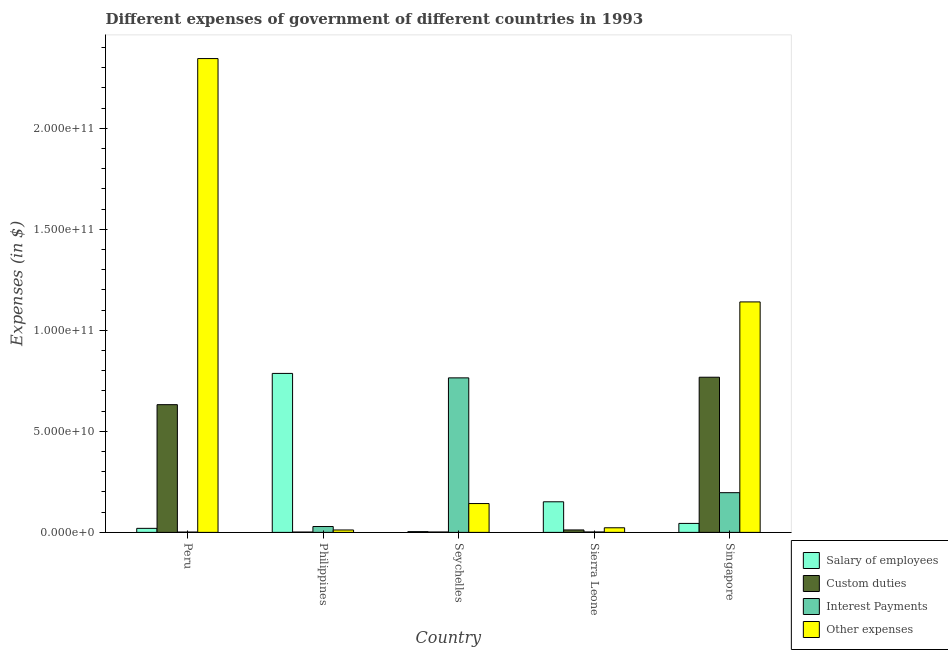How many different coloured bars are there?
Offer a very short reply. 4. How many groups of bars are there?
Ensure brevity in your answer.  5. Are the number of bars per tick equal to the number of legend labels?
Your answer should be very brief. Yes. How many bars are there on the 1st tick from the left?
Give a very brief answer. 4. What is the label of the 5th group of bars from the left?
Make the answer very short. Singapore. In how many cases, is the number of bars for a given country not equal to the number of legend labels?
Ensure brevity in your answer.  0. What is the amount spent on custom duties in Peru?
Your answer should be very brief. 6.32e+1. Across all countries, what is the maximum amount spent on interest payments?
Provide a short and direct response. 7.65e+1. Across all countries, what is the minimum amount spent on interest payments?
Give a very brief answer. 1.57e+08. In which country was the amount spent on custom duties maximum?
Your response must be concise. Singapore. In which country was the amount spent on salary of employees minimum?
Your response must be concise. Seychelles. What is the total amount spent on other expenses in the graph?
Ensure brevity in your answer.  3.66e+11. What is the difference between the amount spent on other expenses in Philippines and that in Seychelles?
Provide a succinct answer. -1.31e+1. What is the difference between the amount spent on custom duties in Sierra Leone and the amount spent on salary of employees in Peru?
Make the answer very short. -7.89e+08. What is the average amount spent on custom duties per country?
Make the answer very short. 2.83e+1. What is the difference between the amount spent on interest payments and amount spent on other expenses in Singapore?
Give a very brief answer. -9.44e+1. In how many countries, is the amount spent on other expenses greater than 220000000000 $?
Provide a succinct answer. 1. What is the ratio of the amount spent on other expenses in Seychelles to that in Singapore?
Make the answer very short. 0.13. Is the amount spent on custom duties in Seychelles less than that in Sierra Leone?
Give a very brief answer. Yes. What is the difference between the highest and the second highest amount spent on interest payments?
Offer a terse response. 5.68e+1. What is the difference between the highest and the lowest amount spent on custom duties?
Give a very brief answer. 7.66e+1. Is the sum of the amount spent on custom duties in Philippines and Singapore greater than the maximum amount spent on salary of employees across all countries?
Provide a short and direct response. No. Is it the case that in every country, the sum of the amount spent on salary of employees and amount spent on custom duties is greater than the sum of amount spent on other expenses and amount spent on interest payments?
Make the answer very short. No. What does the 4th bar from the left in Seychelles represents?
Give a very brief answer. Other expenses. What does the 1st bar from the right in Philippines represents?
Your answer should be compact. Other expenses. How many countries are there in the graph?
Offer a very short reply. 5. What is the difference between two consecutive major ticks on the Y-axis?
Your answer should be very brief. 5.00e+1. Does the graph contain any zero values?
Provide a succinct answer. No. Does the graph contain grids?
Your answer should be very brief. No. What is the title of the graph?
Offer a terse response. Different expenses of government of different countries in 1993. What is the label or title of the X-axis?
Offer a terse response. Country. What is the label or title of the Y-axis?
Offer a terse response. Expenses (in $). What is the Expenses (in $) of Salary of employees in Peru?
Provide a succinct answer. 2.00e+09. What is the Expenses (in $) in Custom duties in Peru?
Keep it short and to the point. 6.32e+1. What is the Expenses (in $) in Interest Payments in Peru?
Ensure brevity in your answer.  1.57e+08. What is the Expenses (in $) in Other expenses in Peru?
Give a very brief answer. 2.35e+11. What is the Expenses (in $) of Salary of employees in Philippines?
Ensure brevity in your answer.  7.87e+1. What is the Expenses (in $) in Custom duties in Philippines?
Make the answer very short. 1.71e+08. What is the Expenses (in $) in Interest Payments in Philippines?
Your answer should be very brief. 2.90e+09. What is the Expenses (in $) of Other expenses in Philippines?
Provide a succinct answer. 1.19e+09. What is the Expenses (in $) in Salary of employees in Seychelles?
Your answer should be compact. 3.80e+08. What is the Expenses (in $) of Custom duties in Seychelles?
Provide a short and direct response. 1.98e+08. What is the Expenses (in $) of Interest Payments in Seychelles?
Offer a terse response. 7.65e+1. What is the Expenses (in $) of Other expenses in Seychelles?
Offer a terse response. 1.43e+1. What is the Expenses (in $) of Salary of employees in Sierra Leone?
Your answer should be very brief. 1.51e+1. What is the Expenses (in $) in Custom duties in Sierra Leone?
Provide a short and direct response. 1.21e+09. What is the Expenses (in $) in Interest Payments in Sierra Leone?
Keep it short and to the point. 2.10e+08. What is the Expenses (in $) in Other expenses in Sierra Leone?
Your response must be concise. 2.28e+09. What is the Expenses (in $) of Salary of employees in Singapore?
Keep it short and to the point. 4.44e+09. What is the Expenses (in $) in Custom duties in Singapore?
Your answer should be compact. 7.68e+1. What is the Expenses (in $) of Interest Payments in Singapore?
Your answer should be compact. 1.97e+1. What is the Expenses (in $) of Other expenses in Singapore?
Provide a short and direct response. 1.14e+11. Across all countries, what is the maximum Expenses (in $) of Salary of employees?
Provide a short and direct response. 7.87e+1. Across all countries, what is the maximum Expenses (in $) in Custom duties?
Your answer should be very brief. 7.68e+1. Across all countries, what is the maximum Expenses (in $) in Interest Payments?
Provide a succinct answer. 7.65e+1. Across all countries, what is the maximum Expenses (in $) in Other expenses?
Offer a very short reply. 2.35e+11. Across all countries, what is the minimum Expenses (in $) in Salary of employees?
Provide a short and direct response. 3.80e+08. Across all countries, what is the minimum Expenses (in $) of Custom duties?
Your response must be concise. 1.71e+08. Across all countries, what is the minimum Expenses (in $) in Interest Payments?
Your answer should be very brief. 1.57e+08. Across all countries, what is the minimum Expenses (in $) in Other expenses?
Ensure brevity in your answer.  1.19e+09. What is the total Expenses (in $) in Salary of employees in the graph?
Give a very brief answer. 1.01e+11. What is the total Expenses (in $) in Custom duties in the graph?
Offer a very short reply. 1.42e+11. What is the total Expenses (in $) in Interest Payments in the graph?
Your response must be concise. 9.94e+1. What is the total Expenses (in $) in Other expenses in the graph?
Keep it short and to the point. 3.66e+11. What is the difference between the Expenses (in $) of Salary of employees in Peru and that in Philippines?
Your answer should be very brief. -7.67e+1. What is the difference between the Expenses (in $) in Custom duties in Peru and that in Philippines?
Your response must be concise. 6.31e+1. What is the difference between the Expenses (in $) in Interest Payments in Peru and that in Philippines?
Provide a succinct answer. -2.74e+09. What is the difference between the Expenses (in $) in Other expenses in Peru and that in Philippines?
Ensure brevity in your answer.  2.33e+11. What is the difference between the Expenses (in $) of Salary of employees in Peru and that in Seychelles?
Provide a short and direct response. 1.62e+09. What is the difference between the Expenses (in $) of Custom duties in Peru and that in Seychelles?
Your answer should be compact. 6.30e+1. What is the difference between the Expenses (in $) of Interest Payments in Peru and that in Seychelles?
Keep it short and to the point. -7.63e+1. What is the difference between the Expenses (in $) of Other expenses in Peru and that in Seychelles?
Make the answer very short. 2.20e+11. What is the difference between the Expenses (in $) of Salary of employees in Peru and that in Sierra Leone?
Give a very brief answer. -1.31e+1. What is the difference between the Expenses (in $) of Custom duties in Peru and that in Sierra Leone?
Your answer should be very brief. 6.20e+1. What is the difference between the Expenses (in $) of Interest Payments in Peru and that in Sierra Leone?
Provide a succinct answer. -5.28e+07. What is the difference between the Expenses (in $) of Other expenses in Peru and that in Sierra Leone?
Keep it short and to the point. 2.32e+11. What is the difference between the Expenses (in $) of Salary of employees in Peru and that in Singapore?
Your answer should be very brief. -2.44e+09. What is the difference between the Expenses (in $) of Custom duties in Peru and that in Singapore?
Offer a terse response. -1.36e+1. What is the difference between the Expenses (in $) in Interest Payments in Peru and that in Singapore?
Make the answer very short. -1.95e+1. What is the difference between the Expenses (in $) in Other expenses in Peru and that in Singapore?
Provide a short and direct response. 1.20e+11. What is the difference between the Expenses (in $) in Salary of employees in Philippines and that in Seychelles?
Offer a very short reply. 7.83e+1. What is the difference between the Expenses (in $) in Custom duties in Philippines and that in Seychelles?
Make the answer very short. -2.69e+07. What is the difference between the Expenses (in $) in Interest Payments in Philippines and that in Seychelles?
Your answer should be compact. -7.36e+1. What is the difference between the Expenses (in $) of Other expenses in Philippines and that in Seychelles?
Make the answer very short. -1.31e+1. What is the difference between the Expenses (in $) in Salary of employees in Philippines and that in Sierra Leone?
Provide a short and direct response. 6.36e+1. What is the difference between the Expenses (in $) in Custom duties in Philippines and that in Sierra Leone?
Give a very brief answer. -1.04e+09. What is the difference between the Expenses (in $) of Interest Payments in Philippines and that in Sierra Leone?
Provide a succinct answer. 2.69e+09. What is the difference between the Expenses (in $) of Other expenses in Philippines and that in Sierra Leone?
Offer a terse response. -1.09e+09. What is the difference between the Expenses (in $) in Salary of employees in Philippines and that in Singapore?
Give a very brief answer. 7.43e+1. What is the difference between the Expenses (in $) of Custom duties in Philippines and that in Singapore?
Your response must be concise. -7.66e+1. What is the difference between the Expenses (in $) in Interest Payments in Philippines and that in Singapore?
Your answer should be very brief. -1.68e+1. What is the difference between the Expenses (in $) of Other expenses in Philippines and that in Singapore?
Keep it short and to the point. -1.13e+11. What is the difference between the Expenses (in $) in Salary of employees in Seychelles and that in Sierra Leone?
Make the answer very short. -1.48e+1. What is the difference between the Expenses (in $) in Custom duties in Seychelles and that in Sierra Leone?
Offer a very short reply. -1.01e+09. What is the difference between the Expenses (in $) of Interest Payments in Seychelles and that in Sierra Leone?
Your response must be concise. 7.63e+1. What is the difference between the Expenses (in $) in Other expenses in Seychelles and that in Sierra Leone?
Your answer should be very brief. 1.20e+1. What is the difference between the Expenses (in $) of Salary of employees in Seychelles and that in Singapore?
Your response must be concise. -4.06e+09. What is the difference between the Expenses (in $) in Custom duties in Seychelles and that in Singapore?
Give a very brief answer. -7.66e+1. What is the difference between the Expenses (in $) of Interest Payments in Seychelles and that in Singapore?
Your response must be concise. 5.68e+1. What is the difference between the Expenses (in $) in Other expenses in Seychelles and that in Singapore?
Provide a succinct answer. -9.98e+1. What is the difference between the Expenses (in $) in Salary of employees in Sierra Leone and that in Singapore?
Your answer should be compact. 1.07e+1. What is the difference between the Expenses (in $) of Custom duties in Sierra Leone and that in Singapore?
Keep it short and to the point. -7.56e+1. What is the difference between the Expenses (in $) of Interest Payments in Sierra Leone and that in Singapore?
Your response must be concise. -1.94e+1. What is the difference between the Expenses (in $) in Other expenses in Sierra Leone and that in Singapore?
Keep it short and to the point. -1.12e+11. What is the difference between the Expenses (in $) of Salary of employees in Peru and the Expenses (in $) of Custom duties in Philippines?
Offer a very short reply. 1.83e+09. What is the difference between the Expenses (in $) in Salary of employees in Peru and the Expenses (in $) in Interest Payments in Philippines?
Offer a very short reply. -9.03e+08. What is the difference between the Expenses (in $) in Salary of employees in Peru and the Expenses (in $) in Other expenses in Philippines?
Keep it short and to the point. 8.09e+08. What is the difference between the Expenses (in $) in Custom duties in Peru and the Expenses (in $) in Interest Payments in Philippines?
Provide a succinct answer. 6.03e+1. What is the difference between the Expenses (in $) in Custom duties in Peru and the Expenses (in $) in Other expenses in Philippines?
Your answer should be very brief. 6.20e+1. What is the difference between the Expenses (in $) in Interest Payments in Peru and the Expenses (in $) in Other expenses in Philippines?
Offer a terse response. -1.03e+09. What is the difference between the Expenses (in $) in Salary of employees in Peru and the Expenses (in $) in Custom duties in Seychelles?
Your answer should be compact. 1.80e+09. What is the difference between the Expenses (in $) of Salary of employees in Peru and the Expenses (in $) of Interest Payments in Seychelles?
Your answer should be compact. -7.45e+1. What is the difference between the Expenses (in $) of Salary of employees in Peru and the Expenses (in $) of Other expenses in Seychelles?
Keep it short and to the point. -1.23e+1. What is the difference between the Expenses (in $) of Custom duties in Peru and the Expenses (in $) of Interest Payments in Seychelles?
Provide a short and direct response. -1.33e+1. What is the difference between the Expenses (in $) of Custom duties in Peru and the Expenses (in $) of Other expenses in Seychelles?
Keep it short and to the point. 4.90e+1. What is the difference between the Expenses (in $) of Interest Payments in Peru and the Expenses (in $) of Other expenses in Seychelles?
Ensure brevity in your answer.  -1.41e+1. What is the difference between the Expenses (in $) in Salary of employees in Peru and the Expenses (in $) in Custom duties in Sierra Leone?
Your answer should be compact. 7.89e+08. What is the difference between the Expenses (in $) in Salary of employees in Peru and the Expenses (in $) in Interest Payments in Sierra Leone?
Give a very brief answer. 1.79e+09. What is the difference between the Expenses (in $) in Salary of employees in Peru and the Expenses (in $) in Other expenses in Sierra Leone?
Provide a short and direct response. -2.80e+08. What is the difference between the Expenses (in $) of Custom duties in Peru and the Expenses (in $) of Interest Payments in Sierra Leone?
Provide a succinct answer. 6.30e+1. What is the difference between the Expenses (in $) in Custom duties in Peru and the Expenses (in $) in Other expenses in Sierra Leone?
Ensure brevity in your answer.  6.09e+1. What is the difference between the Expenses (in $) in Interest Payments in Peru and the Expenses (in $) in Other expenses in Sierra Leone?
Your answer should be very brief. -2.12e+09. What is the difference between the Expenses (in $) of Salary of employees in Peru and the Expenses (in $) of Custom duties in Singapore?
Provide a short and direct response. -7.48e+1. What is the difference between the Expenses (in $) of Salary of employees in Peru and the Expenses (in $) of Interest Payments in Singapore?
Provide a succinct answer. -1.77e+1. What is the difference between the Expenses (in $) in Salary of employees in Peru and the Expenses (in $) in Other expenses in Singapore?
Provide a short and direct response. -1.12e+11. What is the difference between the Expenses (in $) in Custom duties in Peru and the Expenses (in $) in Interest Payments in Singapore?
Provide a short and direct response. 4.36e+1. What is the difference between the Expenses (in $) in Custom duties in Peru and the Expenses (in $) in Other expenses in Singapore?
Keep it short and to the point. -5.09e+1. What is the difference between the Expenses (in $) in Interest Payments in Peru and the Expenses (in $) in Other expenses in Singapore?
Give a very brief answer. -1.14e+11. What is the difference between the Expenses (in $) of Salary of employees in Philippines and the Expenses (in $) of Custom duties in Seychelles?
Make the answer very short. 7.85e+1. What is the difference between the Expenses (in $) of Salary of employees in Philippines and the Expenses (in $) of Interest Payments in Seychelles?
Provide a short and direct response. 2.20e+09. What is the difference between the Expenses (in $) in Salary of employees in Philippines and the Expenses (in $) in Other expenses in Seychelles?
Make the answer very short. 6.44e+1. What is the difference between the Expenses (in $) in Custom duties in Philippines and the Expenses (in $) in Interest Payments in Seychelles?
Your response must be concise. -7.63e+1. What is the difference between the Expenses (in $) of Custom duties in Philippines and the Expenses (in $) of Other expenses in Seychelles?
Give a very brief answer. -1.41e+1. What is the difference between the Expenses (in $) in Interest Payments in Philippines and the Expenses (in $) in Other expenses in Seychelles?
Provide a succinct answer. -1.14e+1. What is the difference between the Expenses (in $) of Salary of employees in Philippines and the Expenses (in $) of Custom duties in Sierra Leone?
Give a very brief answer. 7.75e+1. What is the difference between the Expenses (in $) of Salary of employees in Philippines and the Expenses (in $) of Interest Payments in Sierra Leone?
Provide a short and direct response. 7.85e+1. What is the difference between the Expenses (in $) in Salary of employees in Philippines and the Expenses (in $) in Other expenses in Sierra Leone?
Your answer should be very brief. 7.64e+1. What is the difference between the Expenses (in $) of Custom duties in Philippines and the Expenses (in $) of Interest Payments in Sierra Leone?
Provide a short and direct response. -3.86e+07. What is the difference between the Expenses (in $) in Custom duties in Philippines and the Expenses (in $) in Other expenses in Sierra Leone?
Make the answer very short. -2.11e+09. What is the difference between the Expenses (in $) of Interest Payments in Philippines and the Expenses (in $) of Other expenses in Sierra Leone?
Keep it short and to the point. 6.23e+08. What is the difference between the Expenses (in $) of Salary of employees in Philippines and the Expenses (in $) of Custom duties in Singapore?
Your response must be concise. 1.88e+09. What is the difference between the Expenses (in $) in Salary of employees in Philippines and the Expenses (in $) in Interest Payments in Singapore?
Keep it short and to the point. 5.90e+1. What is the difference between the Expenses (in $) of Salary of employees in Philippines and the Expenses (in $) of Other expenses in Singapore?
Your answer should be very brief. -3.54e+1. What is the difference between the Expenses (in $) of Custom duties in Philippines and the Expenses (in $) of Interest Payments in Singapore?
Your response must be concise. -1.95e+1. What is the difference between the Expenses (in $) in Custom duties in Philippines and the Expenses (in $) in Other expenses in Singapore?
Your answer should be very brief. -1.14e+11. What is the difference between the Expenses (in $) in Interest Payments in Philippines and the Expenses (in $) in Other expenses in Singapore?
Provide a succinct answer. -1.11e+11. What is the difference between the Expenses (in $) of Salary of employees in Seychelles and the Expenses (in $) of Custom duties in Sierra Leone?
Your response must be concise. -8.30e+08. What is the difference between the Expenses (in $) of Salary of employees in Seychelles and the Expenses (in $) of Interest Payments in Sierra Leone?
Your response must be concise. 1.70e+08. What is the difference between the Expenses (in $) in Salary of employees in Seychelles and the Expenses (in $) in Other expenses in Sierra Leone?
Offer a very short reply. -1.90e+09. What is the difference between the Expenses (in $) in Custom duties in Seychelles and the Expenses (in $) in Interest Payments in Sierra Leone?
Provide a succinct answer. -1.17e+07. What is the difference between the Expenses (in $) of Custom duties in Seychelles and the Expenses (in $) of Other expenses in Sierra Leone?
Make the answer very short. -2.08e+09. What is the difference between the Expenses (in $) of Interest Payments in Seychelles and the Expenses (in $) of Other expenses in Sierra Leone?
Make the answer very short. 7.42e+1. What is the difference between the Expenses (in $) in Salary of employees in Seychelles and the Expenses (in $) in Custom duties in Singapore?
Provide a succinct answer. -7.64e+1. What is the difference between the Expenses (in $) in Salary of employees in Seychelles and the Expenses (in $) in Interest Payments in Singapore?
Provide a succinct answer. -1.93e+1. What is the difference between the Expenses (in $) of Salary of employees in Seychelles and the Expenses (in $) of Other expenses in Singapore?
Keep it short and to the point. -1.14e+11. What is the difference between the Expenses (in $) of Custom duties in Seychelles and the Expenses (in $) of Interest Payments in Singapore?
Offer a very short reply. -1.95e+1. What is the difference between the Expenses (in $) of Custom duties in Seychelles and the Expenses (in $) of Other expenses in Singapore?
Provide a succinct answer. -1.14e+11. What is the difference between the Expenses (in $) in Interest Payments in Seychelles and the Expenses (in $) in Other expenses in Singapore?
Your response must be concise. -3.76e+1. What is the difference between the Expenses (in $) in Salary of employees in Sierra Leone and the Expenses (in $) in Custom duties in Singapore?
Your answer should be compact. -6.17e+1. What is the difference between the Expenses (in $) in Salary of employees in Sierra Leone and the Expenses (in $) in Interest Payments in Singapore?
Provide a short and direct response. -4.51e+09. What is the difference between the Expenses (in $) in Salary of employees in Sierra Leone and the Expenses (in $) in Other expenses in Singapore?
Offer a terse response. -9.90e+1. What is the difference between the Expenses (in $) in Custom duties in Sierra Leone and the Expenses (in $) in Interest Payments in Singapore?
Give a very brief answer. -1.84e+1. What is the difference between the Expenses (in $) in Custom duties in Sierra Leone and the Expenses (in $) in Other expenses in Singapore?
Ensure brevity in your answer.  -1.13e+11. What is the difference between the Expenses (in $) in Interest Payments in Sierra Leone and the Expenses (in $) in Other expenses in Singapore?
Offer a terse response. -1.14e+11. What is the average Expenses (in $) in Salary of employees per country?
Your answer should be compact. 2.01e+1. What is the average Expenses (in $) in Custom duties per country?
Your answer should be compact. 2.83e+1. What is the average Expenses (in $) in Interest Payments per country?
Give a very brief answer. 1.99e+1. What is the average Expenses (in $) of Other expenses per country?
Your response must be concise. 7.33e+1. What is the difference between the Expenses (in $) of Salary of employees and Expenses (in $) of Custom duties in Peru?
Ensure brevity in your answer.  -6.12e+1. What is the difference between the Expenses (in $) in Salary of employees and Expenses (in $) in Interest Payments in Peru?
Ensure brevity in your answer.  1.84e+09. What is the difference between the Expenses (in $) in Salary of employees and Expenses (in $) in Other expenses in Peru?
Your answer should be very brief. -2.33e+11. What is the difference between the Expenses (in $) of Custom duties and Expenses (in $) of Interest Payments in Peru?
Make the answer very short. 6.31e+1. What is the difference between the Expenses (in $) in Custom duties and Expenses (in $) in Other expenses in Peru?
Offer a very short reply. -1.71e+11. What is the difference between the Expenses (in $) in Interest Payments and Expenses (in $) in Other expenses in Peru?
Keep it short and to the point. -2.34e+11. What is the difference between the Expenses (in $) of Salary of employees and Expenses (in $) of Custom duties in Philippines?
Provide a short and direct response. 7.85e+1. What is the difference between the Expenses (in $) in Salary of employees and Expenses (in $) in Interest Payments in Philippines?
Your response must be concise. 7.58e+1. What is the difference between the Expenses (in $) in Salary of employees and Expenses (in $) in Other expenses in Philippines?
Your answer should be very brief. 7.75e+1. What is the difference between the Expenses (in $) of Custom duties and Expenses (in $) of Interest Payments in Philippines?
Your answer should be very brief. -2.73e+09. What is the difference between the Expenses (in $) of Custom duties and Expenses (in $) of Other expenses in Philippines?
Your answer should be compact. -1.02e+09. What is the difference between the Expenses (in $) of Interest Payments and Expenses (in $) of Other expenses in Philippines?
Keep it short and to the point. 1.71e+09. What is the difference between the Expenses (in $) in Salary of employees and Expenses (in $) in Custom duties in Seychelles?
Give a very brief answer. 1.82e+08. What is the difference between the Expenses (in $) in Salary of employees and Expenses (in $) in Interest Payments in Seychelles?
Your answer should be very brief. -7.61e+1. What is the difference between the Expenses (in $) of Salary of employees and Expenses (in $) of Other expenses in Seychelles?
Offer a very short reply. -1.39e+1. What is the difference between the Expenses (in $) of Custom duties and Expenses (in $) of Interest Payments in Seychelles?
Offer a terse response. -7.63e+1. What is the difference between the Expenses (in $) of Custom duties and Expenses (in $) of Other expenses in Seychelles?
Make the answer very short. -1.41e+1. What is the difference between the Expenses (in $) in Interest Payments and Expenses (in $) in Other expenses in Seychelles?
Your response must be concise. 6.22e+1. What is the difference between the Expenses (in $) in Salary of employees and Expenses (in $) in Custom duties in Sierra Leone?
Offer a very short reply. 1.39e+1. What is the difference between the Expenses (in $) of Salary of employees and Expenses (in $) of Interest Payments in Sierra Leone?
Offer a very short reply. 1.49e+1. What is the difference between the Expenses (in $) in Salary of employees and Expenses (in $) in Other expenses in Sierra Leone?
Provide a succinct answer. 1.29e+1. What is the difference between the Expenses (in $) in Custom duties and Expenses (in $) in Interest Payments in Sierra Leone?
Provide a short and direct response. 1.00e+09. What is the difference between the Expenses (in $) of Custom duties and Expenses (in $) of Other expenses in Sierra Leone?
Keep it short and to the point. -1.07e+09. What is the difference between the Expenses (in $) of Interest Payments and Expenses (in $) of Other expenses in Sierra Leone?
Provide a succinct answer. -2.07e+09. What is the difference between the Expenses (in $) in Salary of employees and Expenses (in $) in Custom duties in Singapore?
Offer a terse response. -7.24e+1. What is the difference between the Expenses (in $) of Salary of employees and Expenses (in $) of Interest Payments in Singapore?
Your answer should be compact. -1.52e+1. What is the difference between the Expenses (in $) in Salary of employees and Expenses (in $) in Other expenses in Singapore?
Your answer should be very brief. -1.10e+11. What is the difference between the Expenses (in $) of Custom duties and Expenses (in $) of Interest Payments in Singapore?
Give a very brief answer. 5.72e+1. What is the difference between the Expenses (in $) in Custom duties and Expenses (in $) in Other expenses in Singapore?
Your answer should be very brief. -3.73e+1. What is the difference between the Expenses (in $) of Interest Payments and Expenses (in $) of Other expenses in Singapore?
Ensure brevity in your answer.  -9.44e+1. What is the ratio of the Expenses (in $) of Salary of employees in Peru to that in Philippines?
Ensure brevity in your answer.  0.03. What is the ratio of the Expenses (in $) of Custom duties in Peru to that in Philippines?
Offer a terse response. 369.3. What is the ratio of the Expenses (in $) in Interest Payments in Peru to that in Philippines?
Give a very brief answer. 0.05. What is the ratio of the Expenses (in $) in Other expenses in Peru to that in Philippines?
Offer a terse response. 197.1. What is the ratio of the Expenses (in $) in Salary of employees in Peru to that in Seychelles?
Keep it short and to the point. 5.26. What is the ratio of the Expenses (in $) in Custom duties in Peru to that in Seychelles?
Ensure brevity in your answer.  319.12. What is the ratio of the Expenses (in $) of Interest Payments in Peru to that in Seychelles?
Your answer should be compact. 0. What is the ratio of the Expenses (in $) in Other expenses in Peru to that in Seychelles?
Your response must be concise. 16.43. What is the ratio of the Expenses (in $) of Salary of employees in Peru to that in Sierra Leone?
Offer a terse response. 0.13. What is the ratio of the Expenses (in $) in Custom duties in Peru to that in Sierra Leone?
Your answer should be compact. 52.25. What is the ratio of the Expenses (in $) in Interest Payments in Peru to that in Sierra Leone?
Give a very brief answer. 0.75. What is the ratio of the Expenses (in $) in Other expenses in Peru to that in Sierra Leone?
Ensure brevity in your answer.  102.93. What is the ratio of the Expenses (in $) in Salary of employees in Peru to that in Singapore?
Keep it short and to the point. 0.45. What is the ratio of the Expenses (in $) in Custom duties in Peru to that in Singapore?
Provide a succinct answer. 0.82. What is the ratio of the Expenses (in $) in Interest Payments in Peru to that in Singapore?
Provide a succinct answer. 0.01. What is the ratio of the Expenses (in $) in Other expenses in Peru to that in Singapore?
Offer a very short reply. 2.06. What is the ratio of the Expenses (in $) in Salary of employees in Philippines to that in Seychelles?
Your answer should be compact. 207.09. What is the ratio of the Expenses (in $) of Custom duties in Philippines to that in Seychelles?
Offer a terse response. 0.86. What is the ratio of the Expenses (in $) in Interest Payments in Philippines to that in Seychelles?
Provide a short and direct response. 0.04. What is the ratio of the Expenses (in $) in Other expenses in Philippines to that in Seychelles?
Provide a succinct answer. 0.08. What is the ratio of the Expenses (in $) of Salary of employees in Philippines to that in Sierra Leone?
Offer a very short reply. 5.2. What is the ratio of the Expenses (in $) in Custom duties in Philippines to that in Sierra Leone?
Ensure brevity in your answer.  0.14. What is the ratio of the Expenses (in $) in Interest Payments in Philippines to that in Sierra Leone?
Make the answer very short. 13.83. What is the ratio of the Expenses (in $) in Other expenses in Philippines to that in Sierra Leone?
Your answer should be compact. 0.52. What is the ratio of the Expenses (in $) of Salary of employees in Philippines to that in Singapore?
Offer a very short reply. 17.71. What is the ratio of the Expenses (in $) of Custom duties in Philippines to that in Singapore?
Ensure brevity in your answer.  0. What is the ratio of the Expenses (in $) in Interest Payments in Philippines to that in Singapore?
Your answer should be compact. 0.15. What is the ratio of the Expenses (in $) in Other expenses in Philippines to that in Singapore?
Offer a very short reply. 0.01. What is the ratio of the Expenses (in $) in Salary of employees in Seychelles to that in Sierra Leone?
Your response must be concise. 0.03. What is the ratio of the Expenses (in $) in Custom duties in Seychelles to that in Sierra Leone?
Your answer should be compact. 0.16. What is the ratio of the Expenses (in $) in Interest Payments in Seychelles to that in Sierra Leone?
Your response must be concise. 364.59. What is the ratio of the Expenses (in $) in Other expenses in Seychelles to that in Sierra Leone?
Your answer should be compact. 6.26. What is the ratio of the Expenses (in $) in Salary of employees in Seychelles to that in Singapore?
Provide a short and direct response. 0.09. What is the ratio of the Expenses (in $) in Custom duties in Seychelles to that in Singapore?
Provide a succinct answer. 0. What is the ratio of the Expenses (in $) of Interest Payments in Seychelles to that in Singapore?
Keep it short and to the point. 3.89. What is the ratio of the Expenses (in $) in Other expenses in Seychelles to that in Singapore?
Ensure brevity in your answer.  0.13. What is the ratio of the Expenses (in $) of Salary of employees in Sierra Leone to that in Singapore?
Ensure brevity in your answer.  3.41. What is the ratio of the Expenses (in $) of Custom duties in Sierra Leone to that in Singapore?
Keep it short and to the point. 0.02. What is the ratio of the Expenses (in $) of Interest Payments in Sierra Leone to that in Singapore?
Offer a very short reply. 0.01. What is the ratio of the Expenses (in $) in Other expenses in Sierra Leone to that in Singapore?
Your answer should be compact. 0.02. What is the difference between the highest and the second highest Expenses (in $) of Salary of employees?
Provide a short and direct response. 6.36e+1. What is the difference between the highest and the second highest Expenses (in $) in Custom duties?
Give a very brief answer. 1.36e+1. What is the difference between the highest and the second highest Expenses (in $) in Interest Payments?
Ensure brevity in your answer.  5.68e+1. What is the difference between the highest and the second highest Expenses (in $) of Other expenses?
Offer a very short reply. 1.20e+11. What is the difference between the highest and the lowest Expenses (in $) in Salary of employees?
Offer a very short reply. 7.83e+1. What is the difference between the highest and the lowest Expenses (in $) of Custom duties?
Your answer should be very brief. 7.66e+1. What is the difference between the highest and the lowest Expenses (in $) of Interest Payments?
Your response must be concise. 7.63e+1. What is the difference between the highest and the lowest Expenses (in $) of Other expenses?
Offer a very short reply. 2.33e+11. 